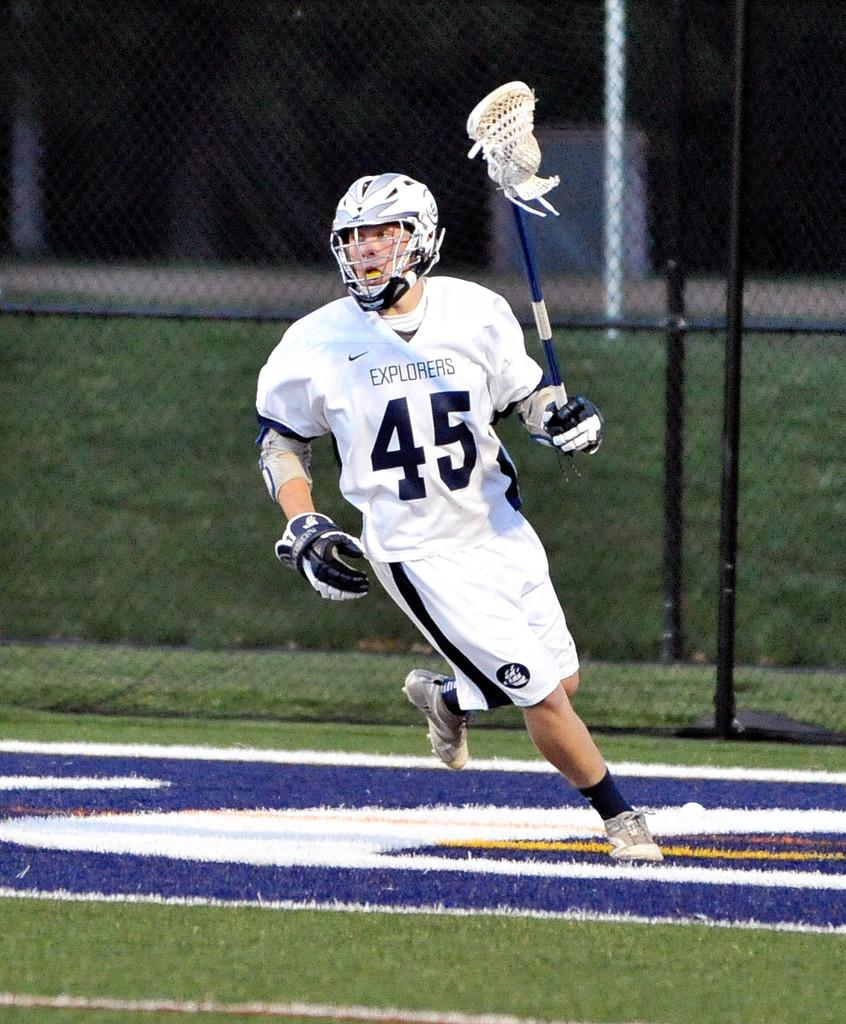What is the person in the image doing? The person is running in a stadium. What protective gear is the person wearing? The person is wearing a helmet. What type of footwear is the person wearing? The person is wearing shoes. What object is the person holding in their hand? The person is holding a bat-like object in their hand. What type of cracker is the person eating while running in the image? There is no cracker present in the image; the person is running with a bat-like object in their hand. 